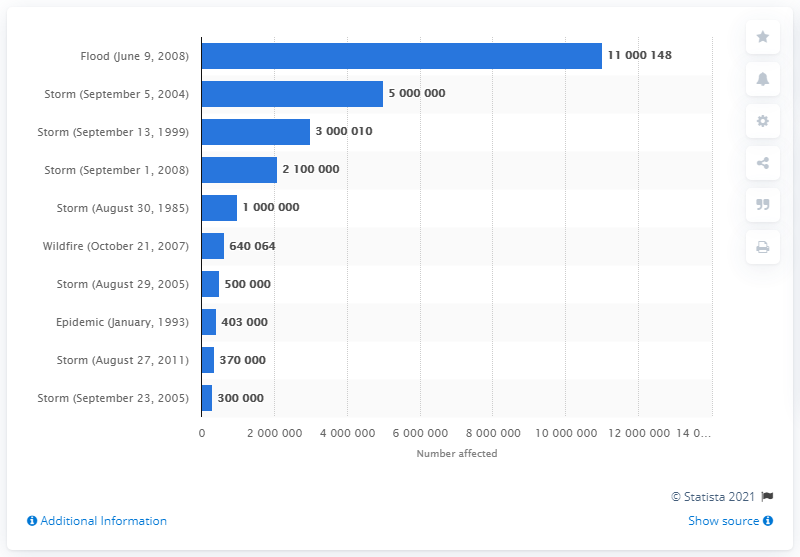Identify some key points in this picture. Hurricane Irene affected a total of 370,000 people in 2011. 